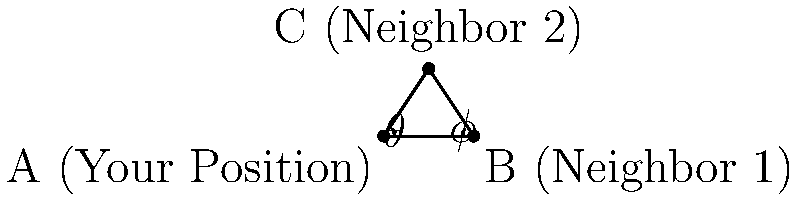From your position at point A, you observe two neighbors' houses at points B and C. The distance between you and Neighbor 1 (point B) is 8 units, and the angle $\theta$ between the line AB and AC is 37°. If the angle $\phi$ at point B is 37°, what is the distance between the two neighbors' houses (length of BC)? Let's approach this step-by-step:

1) First, we can identify that triangle ABC is isosceles. This is because angles $\theta$ and $\phi$ are both 37°, and in a triangle, equal angles are opposite equal sides.

2) Since the triangle is isosceles, we know that AB = AC.

3) We're given that AB = 8 units.

4) In an isosceles triangle, the line from the vertex angle to the midpoint of the opposite side bisects the vertex angle and is perpendicular to the base.

5) Let's call the midpoint of BC as M. Then, AM bisects angle BAC and is perpendicular to BC.

6) This means that triangle ABM is a right-angled triangle, with the right angle at M.

7) In triangle ABM:
   - We know AB = 8
   - Angle BAM = $\frac{1}{2} \theta = \frac{37°}{2} = 18.5°$

8) We can use trigonometry to find BM:

   $\cos(18.5°) = \frac{BM}{8}$

   $BM = 8 \cos(18.5°) \approx 7.59$ units

9) Since M is the midpoint of BC, the length of BC is twice BM:

   $BC = 2 * 7.59 \approx 15.18$ units

Therefore, the distance between the two neighbors' houses is approximately 15.18 units.
Answer: 15.18 units 